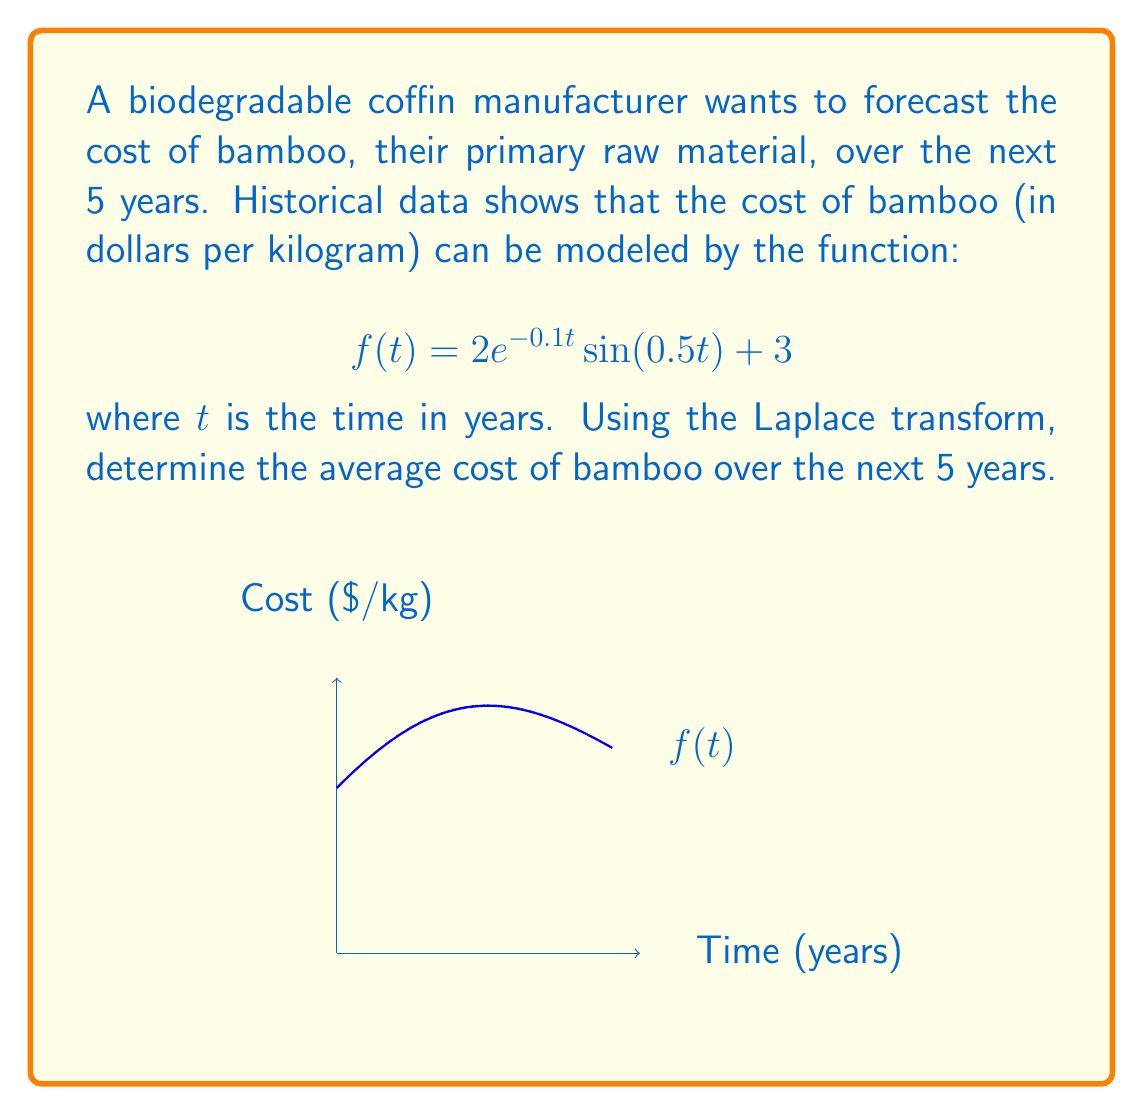Can you solve this math problem? To solve this problem, we'll use the following steps:

1) The average cost over 5 years is given by:

   $$\frac{1}{5}\int_0^5 f(t)dt$$

2) We can use the Laplace transform to evaluate this integral. Recall that:

   $$\mathcal{L}\{f(t)\} = F(s) = \int_0^\infty e^{-st}f(t)dt$$

3) The average can be expressed in terms of $F(s)$:

   $$\frac{1}{5}\int_0^5 f(t)dt = \frac{1}{5}\left.\frac{F(s)}{s}\right|_{s=0}$$

4) Now, let's find $F(s)$. We know that:

   $$\mathcal{L}\{e^{at}\sin(bt)\} = \frac{b}{(s-a)^2 + b^2}$$

   $$\mathcal{L}\{1\} = \frac{1}{s}$$

5) Therefore:

   $$F(s) = 2\cdot\frac{0.5}{(s+0.1)^2 + 0.5^2} + \frac{3}{s}$$

6) Simplify:

   $$F(s) = \frac{1}{(s+0.1)^2 + 0.25} + \frac{3}{s}$$

7) Now, we need to evaluate:

   $$\frac{1}{5}\lim_{s\to0}\frac{F(s)}{s} = \frac{1}{5}\lim_{s\to0}\left(\frac{1}{s((s+0.1)^2 + 0.25)} + \frac{3}{s^2}\right)$$

8) As $s$ approaches 0, the first term approaches 4, and the second term approaches infinity. However, we're only interested in the finite part, so:

   $$\frac{1}{5}(4 + \lim_{s\to0}\frac{3}{s})$$

9) The limit of $3/s$ as $s$ approaches 0 represents the average of the constant term 3 over the interval, which is simply 3.

10) Therefore, the final result is:

    $$\frac{1}{5}(4 + 3) = \frac{7}{5} = 1.4$$
Answer: $1.4 per kilogram 